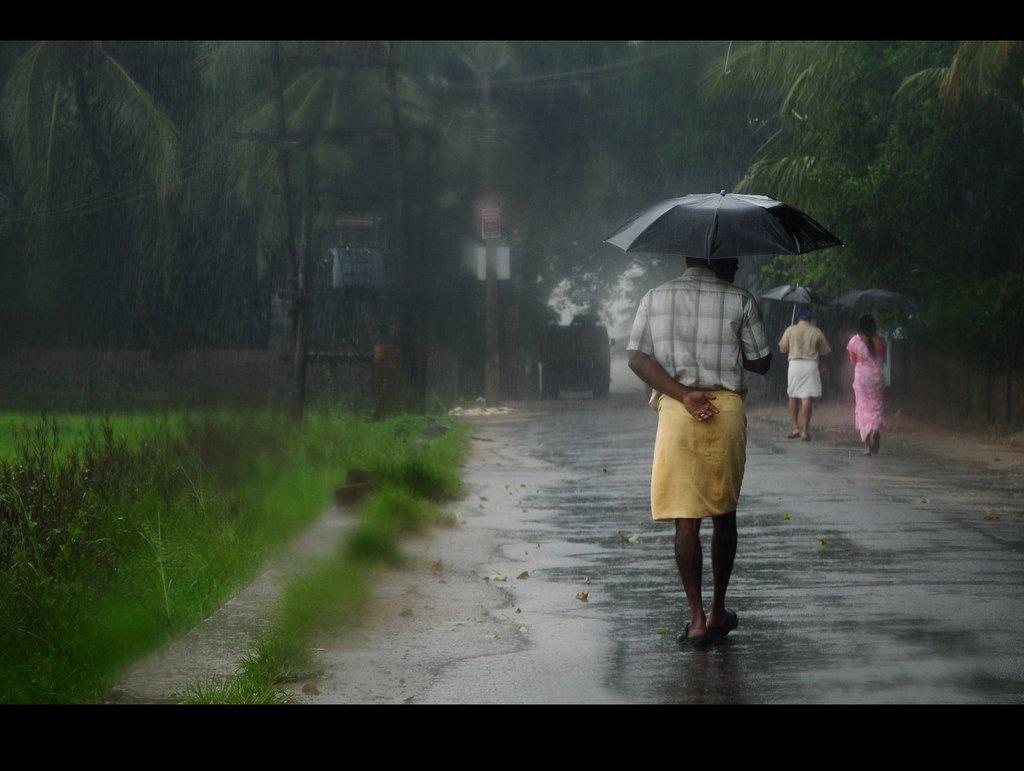How would you summarize this image in a sentence or two? In this image I can see a road on the right side and on it I can see three persons are walking. I can also see they all are holding black colour umbrellas. On the left side of this image I can see grass ground. In the background I can see few poles, wires, few boards and number of trees. 